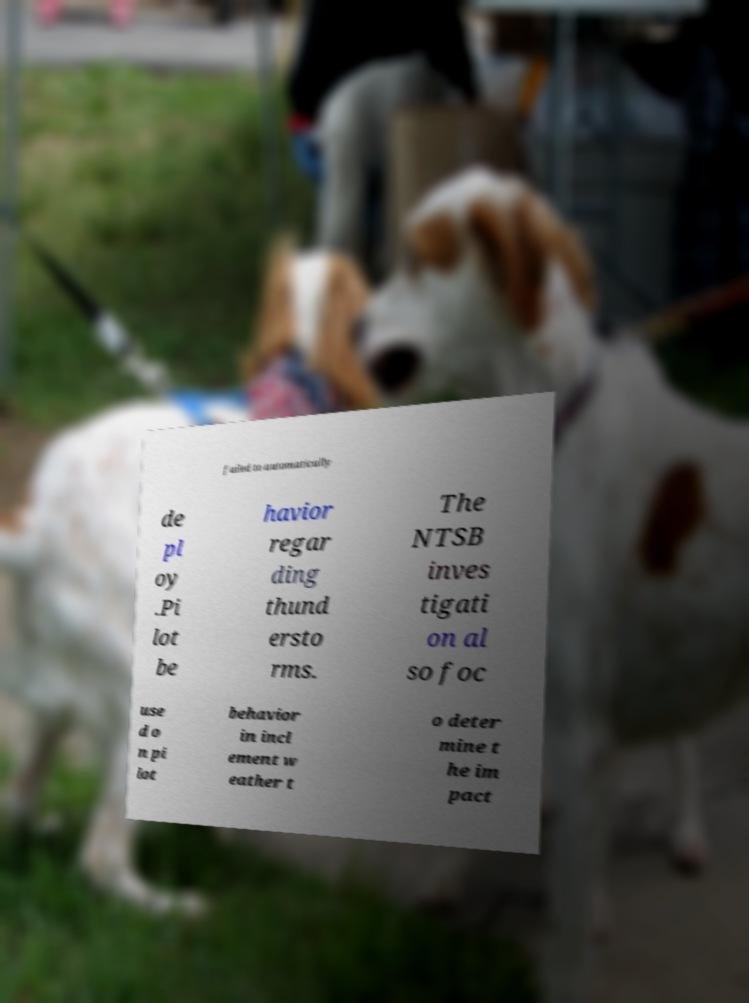For documentation purposes, I need the text within this image transcribed. Could you provide that? failed to automatically de pl oy .Pi lot be havior regar ding thund ersto rms. The NTSB inves tigati on al so foc use d o n pi lot behavior in incl ement w eather t o deter mine t he im pact 